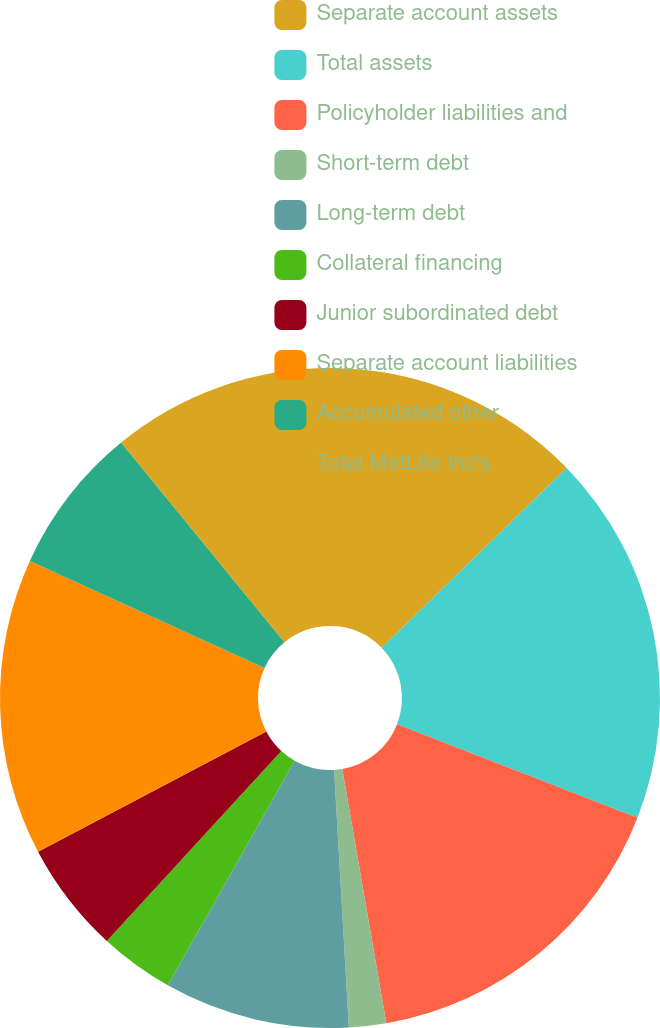<chart> <loc_0><loc_0><loc_500><loc_500><pie_chart><fcel>Separate account assets<fcel>Total assets<fcel>Policyholder liabilities and<fcel>Short-term debt<fcel>Long-term debt<fcel>Collateral financing<fcel>Junior subordinated debt<fcel>Separate account liabilities<fcel>Accumulated other<fcel>Total MetLife Inc's<nl><fcel>12.73%<fcel>18.18%<fcel>16.36%<fcel>1.82%<fcel>9.09%<fcel>3.64%<fcel>5.46%<fcel>14.54%<fcel>7.27%<fcel>10.91%<nl></chart> 